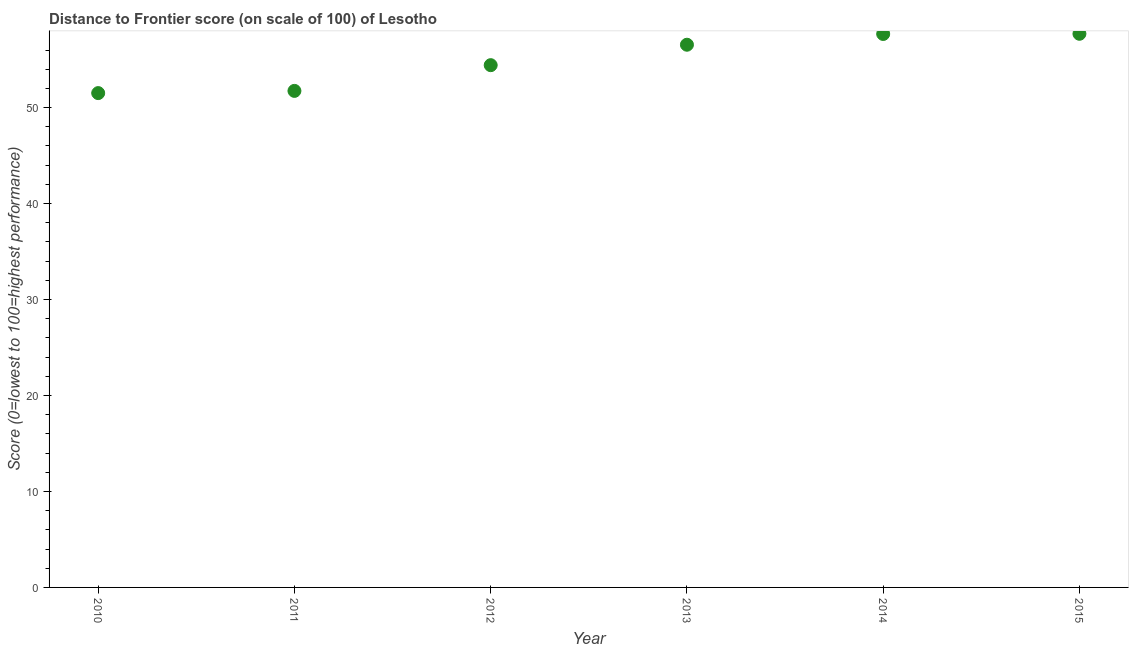What is the distance to frontier score in 2013?
Offer a very short reply. 56.55. Across all years, what is the maximum distance to frontier score?
Your answer should be compact. 57.69. Across all years, what is the minimum distance to frontier score?
Your answer should be very brief. 51.51. In which year was the distance to frontier score maximum?
Your answer should be very brief. 2015. What is the sum of the distance to frontier score?
Provide a short and direct response. 329.58. What is the difference between the distance to frontier score in 2013 and 2015?
Make the answer very short. -1.14. What is the average distance to frontier score per year?
Provide a short and direct response. 54.93. What is the median distance to frontier score?
Make the answer very short. 55.48. In how many years, is the distance to frontier score greater than 2 ?
Offer a very short reply. 6. What is the ratio of the distance to frontier score in 2011 to that in 2014?
Offer a very short reply. 0.9. What is the difference between the highest and the second highest distance to frontier score?
Your response must be concise. 0.02. Is the sum of the distance to frontier score in 2011 and 2012 greater than the maximum distance to frontier score across all years?
Offer a very short reply. Yes. What is the difference between the highest and the lowest distance to frontier score?
Offer a terse response. 6.18. In how many years, is the distance to frontier score greater than the average distance to frontier score taken over all years?
Offer a terse response. 3. Does the graph contain any zero values?
Your answer should be very brief. No. What is the title of the graph?
Offer a terse response. Distance to Frontier score (on scale of 100) of Lesotho. What is the label or title of the Y-axis?
Give a very brief answer. Score (0=lowest to 100=highest performance). What is the Score (0=lowest to 100=highest performance) in 2010?
Your answer should be very brief. 51.51. What is the Score (0=lowest to 100=highest performance) in 2011?
Provide a short and direct response. 51.74. What is the Score (0=lowest to 100=highest performance) in 2012?
Offer a terse response. 54.42. What is the Score (0=lowest to 100=highest performance) in 2013?
Your answer should be very brief. 56.55. What is the Score (0=lowest to 100=highest performance) in 2014?
Provide a succinct answer. 57.67. What is the Score (0=lowest to 100=highest performance) in 2015?
Provide a short and direct response. 57.69. What is the difference between the Score (0=lowest to 100=highest performance) in 2010 and 2011?
Your response must be concise. -0.23. What is the difference between the Score (0=lowest to 100=highest performance) in 2010 and 2012?
Your answer should be compact. -2.91. What is the difference between the Score (0=lowest to 100=highest performance) in 2010 and 2013?
Give a very brief answer. -5.04. What is the difference between the Score (0=lowest to 100=highest performance) in 2010 and 2014?
Your answer should be very brief. -6.16. What is the difference between the Score (0=lowest to 100=highest performance) in 2010 and 2015?
Your answer should be very brief. -6.18. What is the difference between the Score (0=lowest to 100=highest performance) in 2011 and 2012?
Give a very brief answer. -2.68. What is the difference between the Score (0=lowest to 100=highest performance) in 2011 and 2013?
Provide a succinct answer. -4.81. What is the difference between the Score (0=lowest to 100=highest performance) in 2011 and 2014?
Your response must be concise. -5.93. What is the difference between the Score (0=lowest to 100=highest performance) in 2011 and 2015?
Keep it short and to the point. -5.95. What is the difference between the Score (0=lowest to 100=highest performance) in 2012 and 2013?
Give a very brief answer. -2.13. What is the difference between the Score (0=lowest to 100=highest performance) in 2012 and 2014?
Make the answer very short. -3.25. What is the difference between the Score (0=lowest to 100=highest performance) in 2012 and 2015?
Make the answer very short. -3.27. What is the difference between the Score (0=lowest to 100=highest performance) in 2013 and 2014?
Keep it short and to the point. -1.12. What is the difference between the Score (0=lowest to 100=highest performance) in 2013 and 2015?
Your answer should be very brief. -1.14. What is the difference between the Score (0=lowest to 100=highest performance) in 2014 and 2015?
Your answer should be very brief. -0.02. What is the ratio of the Score (0=lowest to 100=highest performance) in 2010 to that in 2012?
Offer a terse response. 0.95. What is the ratio of the Score (0=lowest to 100=highest performance) in 2010 to that in 2013?
Your answer should be compact. 0.91. What is the ratio of the Score (0=lowest to 100=highest performance) in 2010 to that in 2014?
Give a very brief answer. 0.89. What is the ratio of the Score (0=lowest to 100=highest performance) in 2010 to that in 2015?
Your answer should be very brief. 0.89. What is the ratio of the Score (0=lowest to 100=highest performance) in 2011 to that in 2012?
Your answer should be very brief. 0.95. What is the ratio of the Score (0=lowest to 100=highest performance) in 2011 to that in 2013?
Offer a very short reply. 0.92. What is the ratio of the Score (0=lowest to 100=highest performance) in 2011 to that in 2014?
Your answer should be very brief. 0.9. What is the ratio of the Score (0=lowest to 100=highest performance) in 2011 to that in 2015?
Keep it short and to the point. 0.9. What is the ratio of the Score (0=lowest to 100=highest performance) in 2012 to that in 2013?
Ensure brevity in your answer.  0.96. What is the ratio of the Score (0=lowest to 100=highest performance) in 2012 to that in 2014?
Provide a succinct answer. 0.94. What is the ratio of the Score (0=lowest to 100=highest performance) in 2012 to that in 2015?
Offer a very short reply. 0.94. What is the ratio of the Score (0=lowest to 100=highest performance) in 2013 to that in 2014?
Give a very brief answer. 0.98. What is the ratio of the Score (0=lowest to 100=highest performance) in 2013 to that in 2015?
Provide a short and direct response. 0.98. 